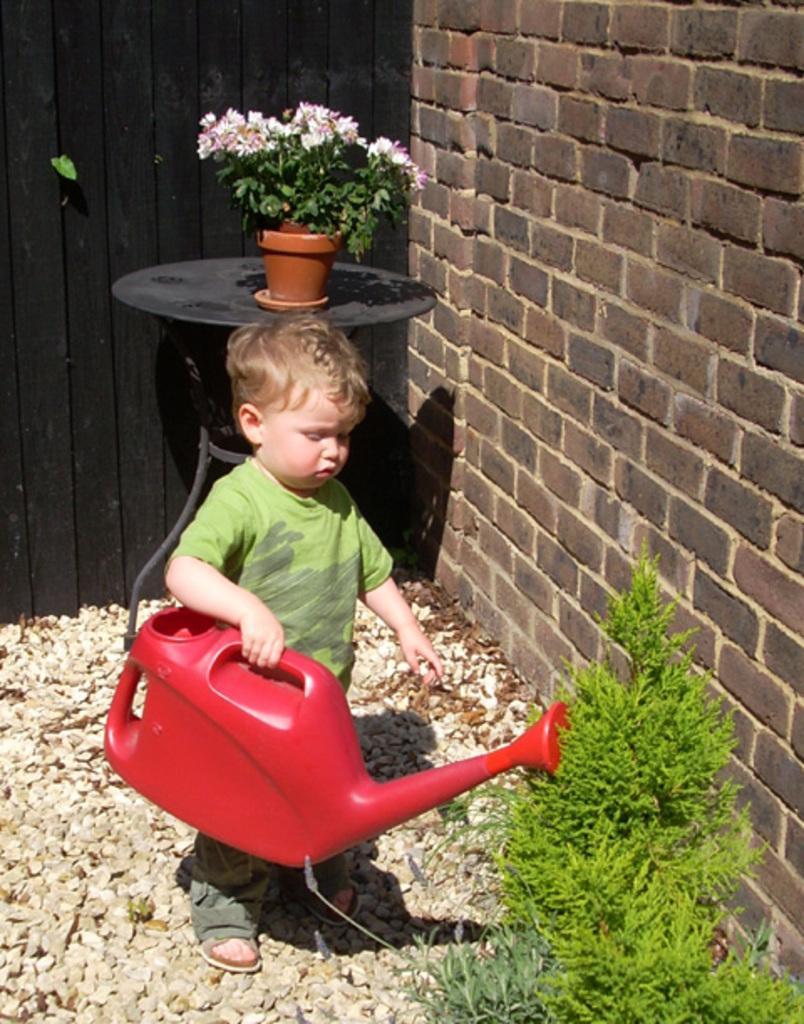In one or two sentences, can you explain what this image depicts? In the foreground of this image, there is a boy holding a red color can on the stones. On the right, there are plants near wall. Behind him, there is a flower vase on the table near a black color wooden wall. 